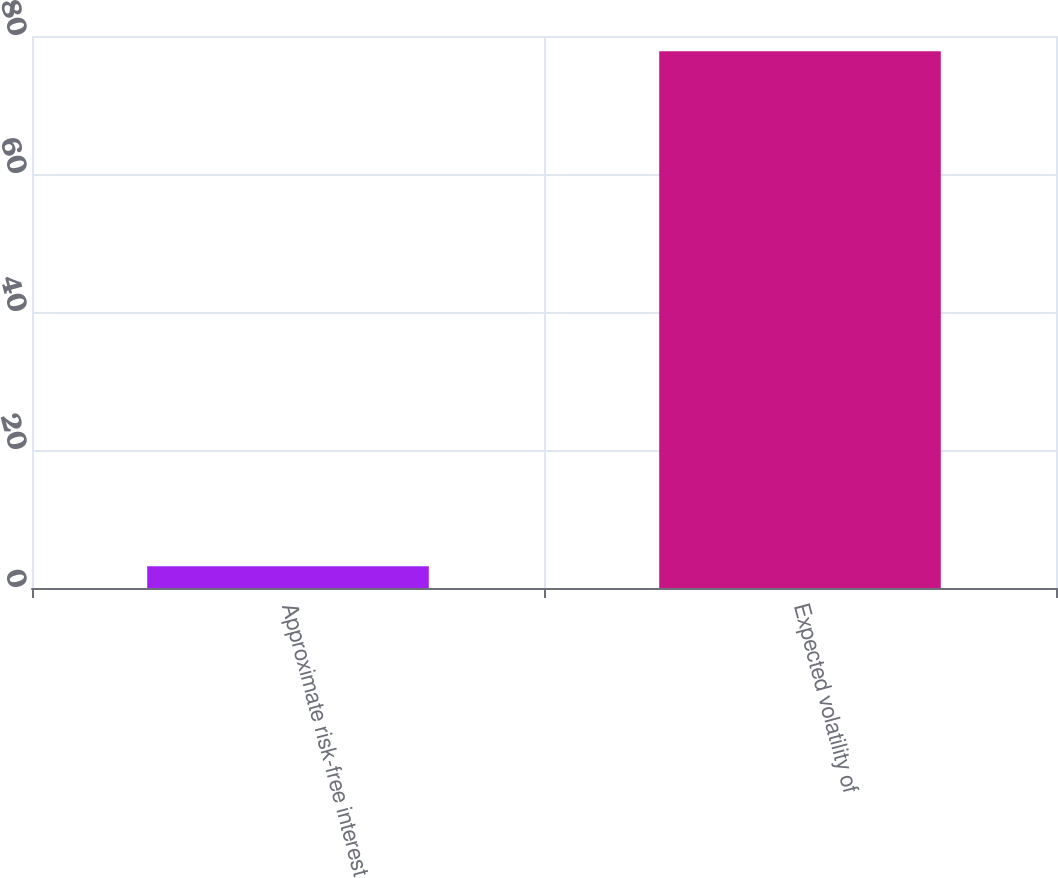Convert chart. <chart><loc_0><loc_0><loc_500><loc_500><bar_chart><fcel>Approximate risk-free interest<fcel>Expected volatility of<nl><fcel>3.17<fcel>77.8<nl></chart> 